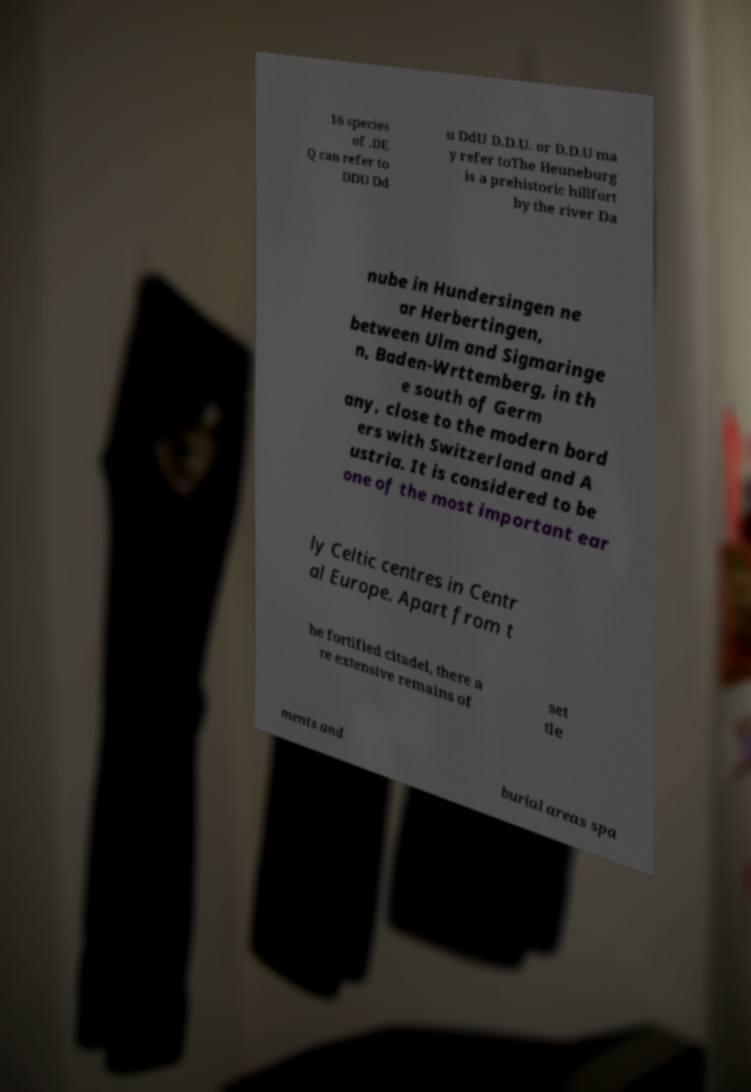Please identify and transcribe the text found in this image. 16 species of .DE Q can refer to DDU Dd u DdU D.D.U. or D.D.U ma y refer toThe Heuneburg is a prehistoric hillfort by the river Da nube in Hundersingen ne ar Herbertingen, between Ulm and Sigmaringe n, Baden-Wrttemberg, in th e south of Germ any, close to the modern bord ers with Switzerland and A ustria. It is considered to be one of the most important ear ly Celtic centres in Centr al Europe. Apart from t he fortified citadel, there a re extensive remains of set tle ments and burial areas spa 